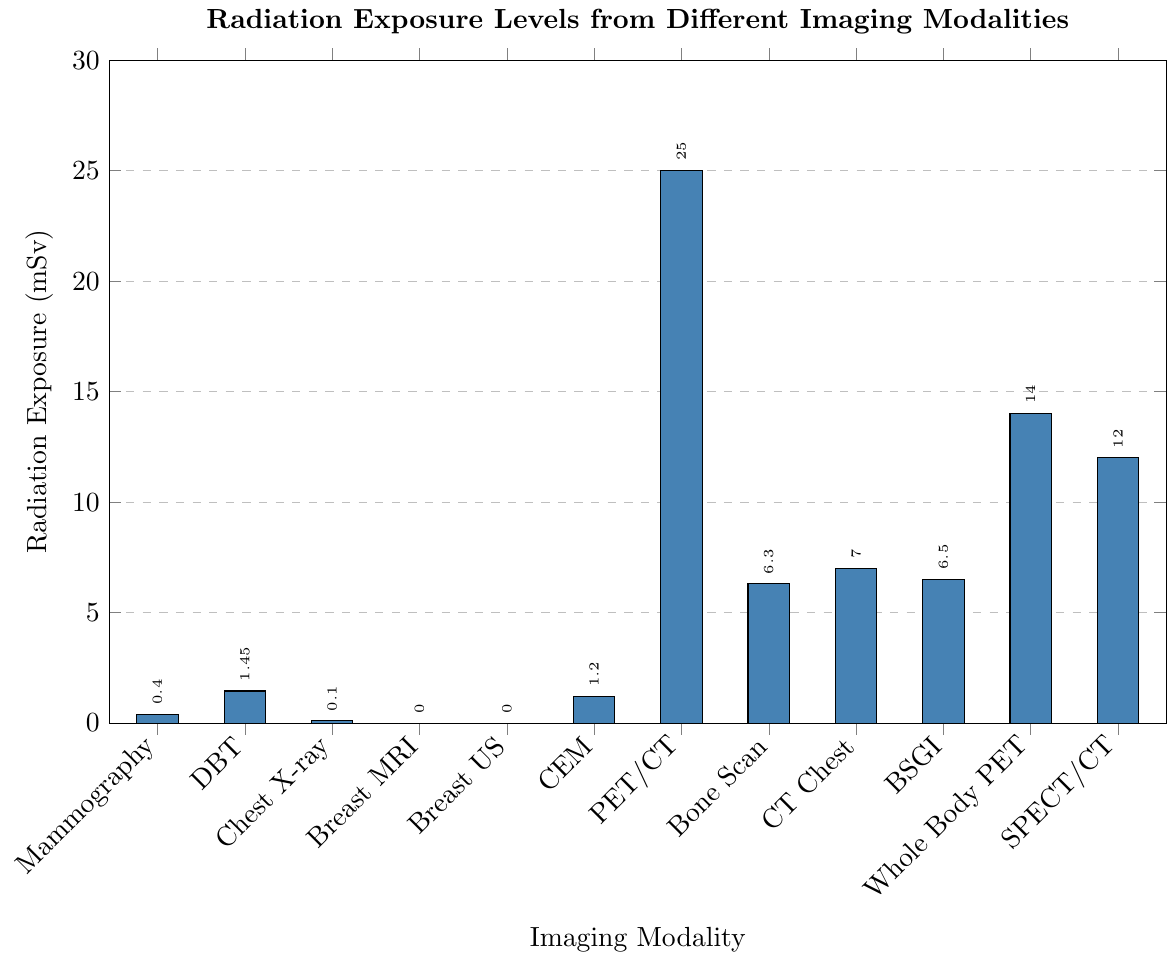What are the imaging modalities that do not involve any radiation exposure? Look for modalities with a radiation exposure level of 0 mSv. Breast MRI and Breast Ultrasound both have 0 mSv radiation exposure.
Answer: Breast MRI and Breast Ultrasound Which imaging modality has the highest radiation exposure? Identify the modality with the tallest bar on the chart. The tallest bar represents PET/CT Scan with 25 mSv.
Answer: PET/CT Scan What is the total radiation exposure of Mammography, Digital Breast Tomosynthesis (DBT), and Contrast-Enhanced Mammography (CEM)? Add the radiation exposure values of Mammography (0.4), DBT (1.45), and CEM (1.2). 0.4 + 1.45 + 1.2 = 3.05 mSv.
Answer: 3.05 mSv How much greater is the radiation exposure of a PET/CT Scan compared to a Chest X-ray? Subtract the radiation exposure of Chest X-ray (0.1) from that of PET/CT Scan (25). 25 - 0.1 = 24.9 mSv.
Answer: 24.9 mSv What is the difference in radiation exposure between a Whole Body PET and a Bone Scan? Subtract the radiation exposure of a Bone Scan (6.3) from that of Whole Body PET (14). 14 - 6.3 = 7.7 mSv.
Answer: 7.7 mSv Which imaging modalities have a radiation exposure level between 5 and 15 mSv? Identify the modalities with bars falling between these values. Bone Scan (6.3), BSGI (6.5), CT Chest (7), Whole Body PET (14), and SPECT/CT (12).
Answer: Bone Scan, BSGI, CT Chest, Whole Body PET, SPECT/CT How does the radiation exposure of Breast-Specific Gamma Imaging (BSGI) compare to that of CT Chest? Compare the heights of the bars for BSGI and CT Chest. BSGI has a radiation exposure of 6.5 mSv, while CT Chest is 7 mSv.
Answer: BSGI is slightly lower than CT Chest What is the average radiation exposure across all imaging modalities that involve radiation? Add all the radiation exposure values and divide by the number of modalities that involve radiation exposure. (0.4 + 1.45 + 0.1 + 1.2 + 25 + 6.3 + 7 + 6.5 + 14 + 12) / 10 = 7.895 mSv.
Answer: 7.9 mSv Which imaging modality has the lowest radiation exposure among those that do contain radiation? Identify the shortest bar for modalities that contain radiation. Chest X-ray has the lowest with 0.1 mSv.
Answer: Chest X-ray What is the sum of the radiation exposures of the imaging modalities that involve gamma rays (PET/CT, BSGI, and SPECT/CT)? Add the radiation exposures of PET/CT (25), BSGI (6.5), and SPECT/CT (12). 25 + 6.5 + 12 = 43.5 mSv.
Answer: 43.5 mSv 